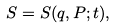<formula> <loc_0><loc_0><loc_500><loc_500>S = S { \left ( { q } , { P } ; t \right ) } ,</formula> 